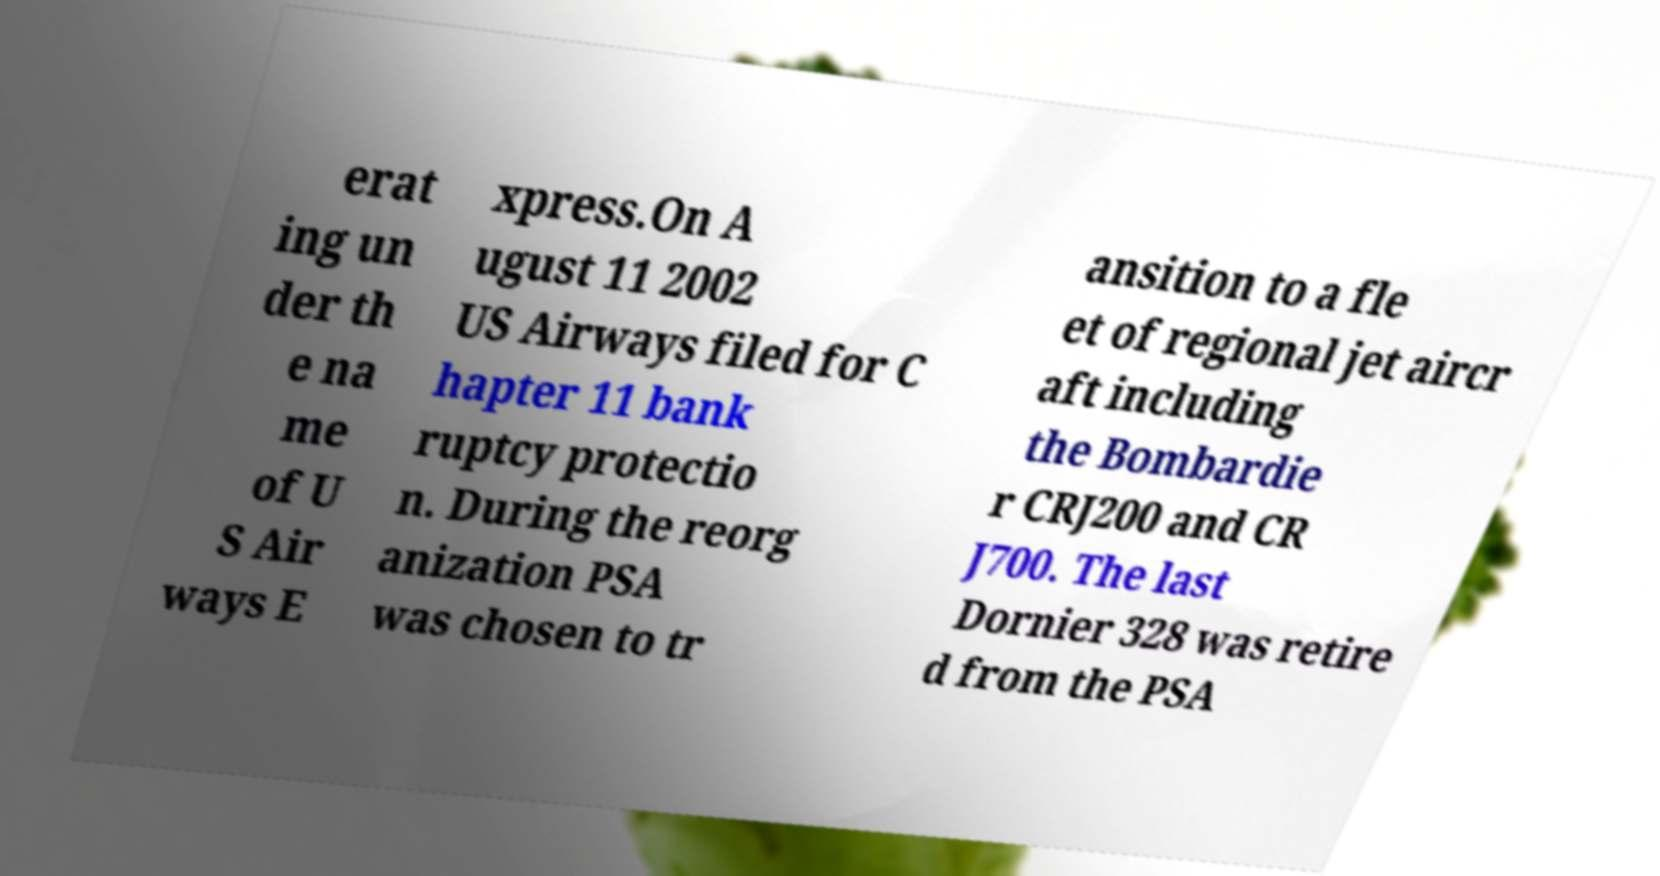Can you read and provide the text displayed in the image?This photo seems to have some interesting text. Can you extract and type it out for me? erat ing un der th e na me of U S Air ways E xpress.On A ugust 11 2002 US Airways filed for C hapter 11 bank ruptcy protectio n. During the reorg anization PSA was chosen to tr ansition to a fle et of regional jet aircr aft including the Bombardie r CRJ200 and CR J700. The last Dornier 328 was retire d from the PSA 